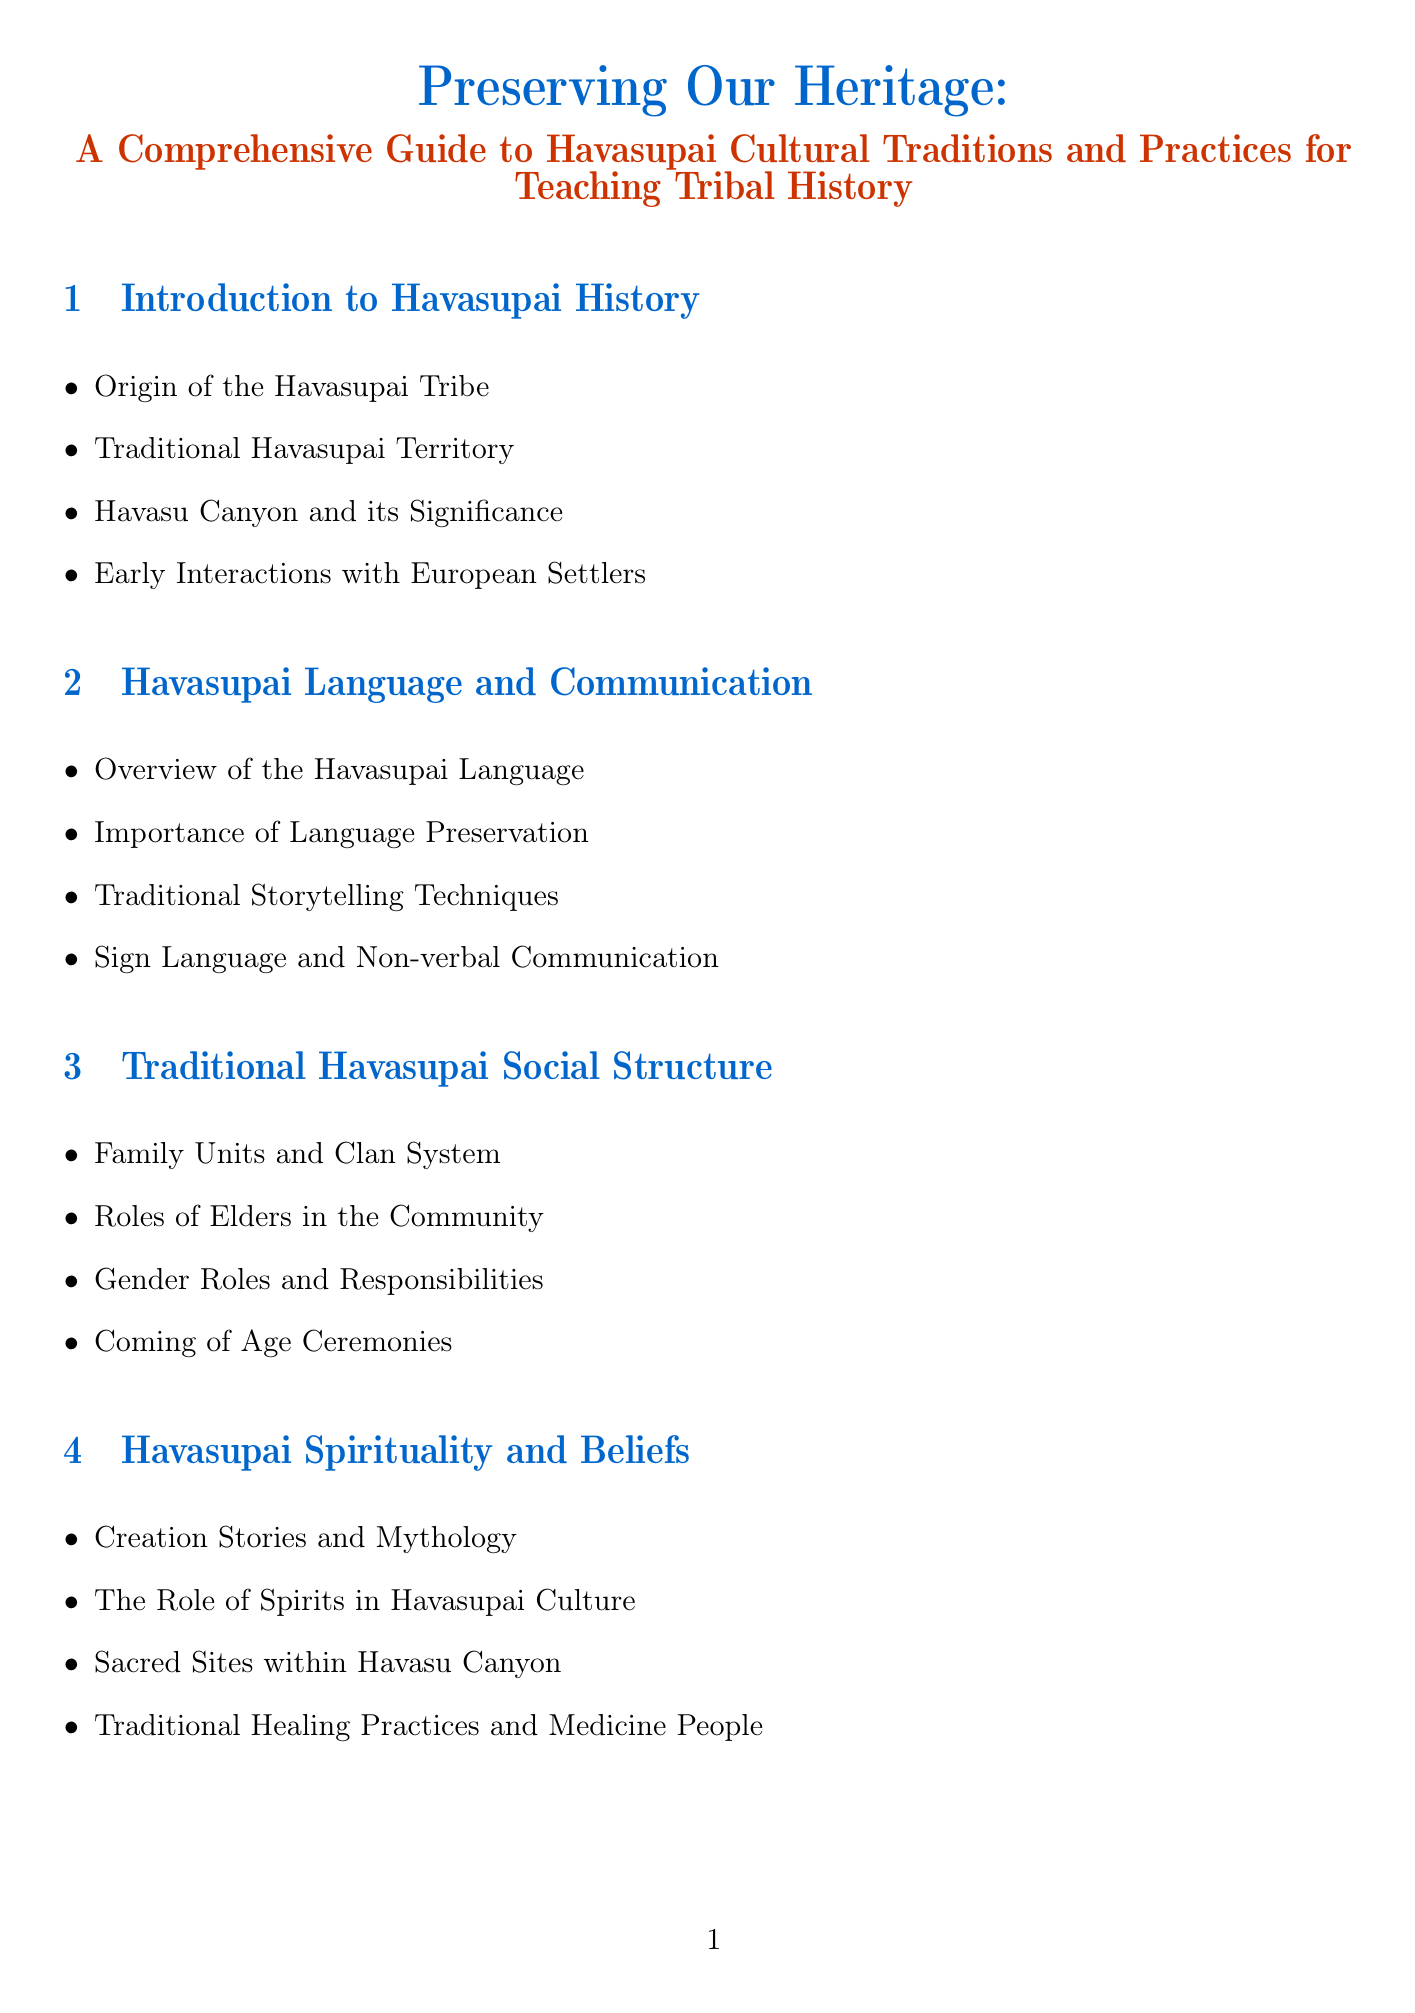What is the main title of the document? The main title is stated at the beginning of the document, giving the overall focus of the guide.
Answer: Preserving Our Heritage: A Comprehensive Guide to Havasupai Cultural Traditions and Practices for Teaching Tribal History Who is the author of "I Am the Grand Canyon"? This question probes into the recommended resources, specifically seeking the author of a key book mentioned.
Answer: Stephen Hirst What is a significant sacred site in Havasu Canyon? This question looks for an important cultural location mentioned in the document related to Havasupai spirituality.
Answer: Havasu Falls Who played a role in negotiating with the U.S. government in the 19th century? This question combines historical context with specific figures in Havasupai history to identify a key leader.
Answer: Chief Navajo What practice is crucial for preserving the Havasupai language? This question connects the importance of language preservation with cultural identity highlighted in the document.
Answer: Importance of Language Preservation What are traditional methods of Havasupai agriculture mentioned? This question seeks a specific aspect from the agricultural practices section to highlight cultural techniques.
Answer: Traditional Farming Methods How many subsections are listed under Havasupai Spirituality and Beliefs? This question requires some evaluation of the structure of the document to determine the number of topics covered in a specific section.
Answer: Four Which tribal school integrates cultural education? This question centers on educational institutions highlighted within the document, looking for a specific school name.
Answer: Havasupai Elementary School What color is associated with the traditional Havasupai music? This question is about elements of Havasupai cultural practices in the document, focusing on one aspect of the arts.
Answer: Traditional Songs and Their Meanings 